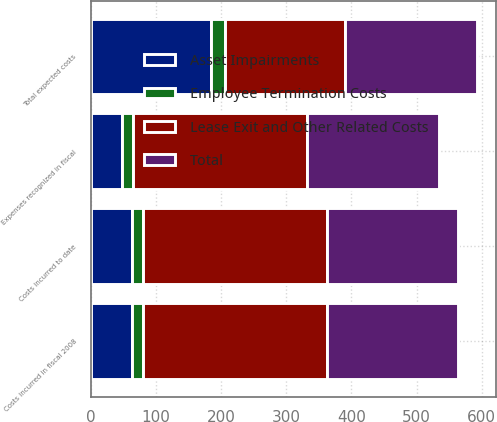<chart> <loc_0><loc_0><loc_500><loc_500><stacked_bar_chart><ecel><fcel>Total expected costs<fcel>Expenses recognized in fiscal<fcel>Costs incurred in fiscal 2008<fcel>Costs incurred to date<nl><fcel>Asset Impairments<fcel>185<fcel>47.8<fcel>62.6<fcel>62.6<nl><fcel>Total<fcel>202.5<fcel>201.6<fcel>201.6<fcel>201.6<nl><fcel>Employee Termination Costs<fcel>20.3<fcel>17.5<fcel>17.5<fcel>17.5<nl><fcel>Lease Exit and Other Related Costs<fcel>185<fcel>266.9<fcel>281.7<fcel>281.7<nl></chart> 